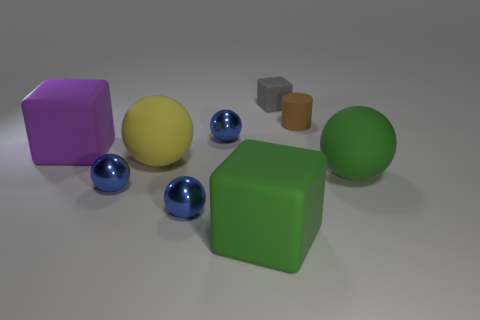How would you describe the lighting and shadows in the scene? The lighting in the scene appears to be diffused, creating soft shadows that extend away from the objects. The shadows are most pronounced beneath and to the right of the objects, suggesting that the main light source is positioned to the top left of the scene. This lighting gives the image a calm, almost studio-like atmosphere. 